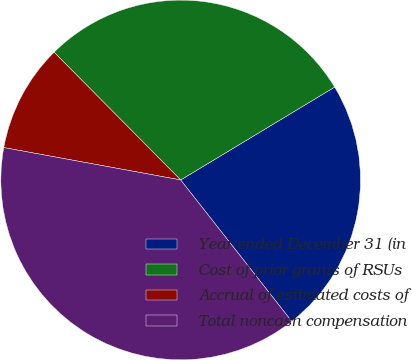Convert chart to OTSL. <chart><loc_0><loc_0><loc_500><loc_500><pie_chart><fcel>Year ended December 31 (in<fcel>Cost of prior grants of RSUs<fcel>Accrual of estimated costs of<fcel>Total noncash compensation<nl><fcel>23.04%<fcel>28.79%<fcel>9.69%<fcel>38.48%<nl></chart> 